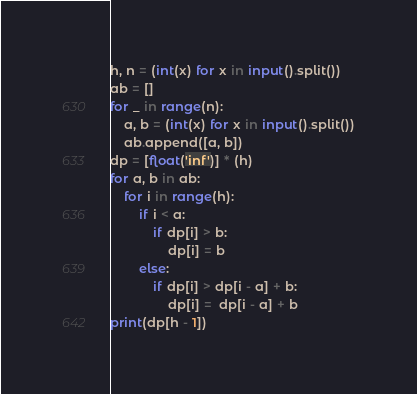Convert code to text. <code><loc_0><loc_0><loc_500><loc_500><_Python_>h, n = (int(x) for x in input().split())
ab = []
for _ in range(n):
    a, b = (int(x) for x in input().split())
    ab.append([a, b])
dp = [float('inf')] * (h)
for a, b in ab:
    for i in range(h):
        if i < a:
            if dp[i] > b:
                dp[i] = b
        else:
            if dp[i] > dp[i - a] + b:
                dp[i] =  dp[i - a] + b
print(dp[h - 1])</code> 